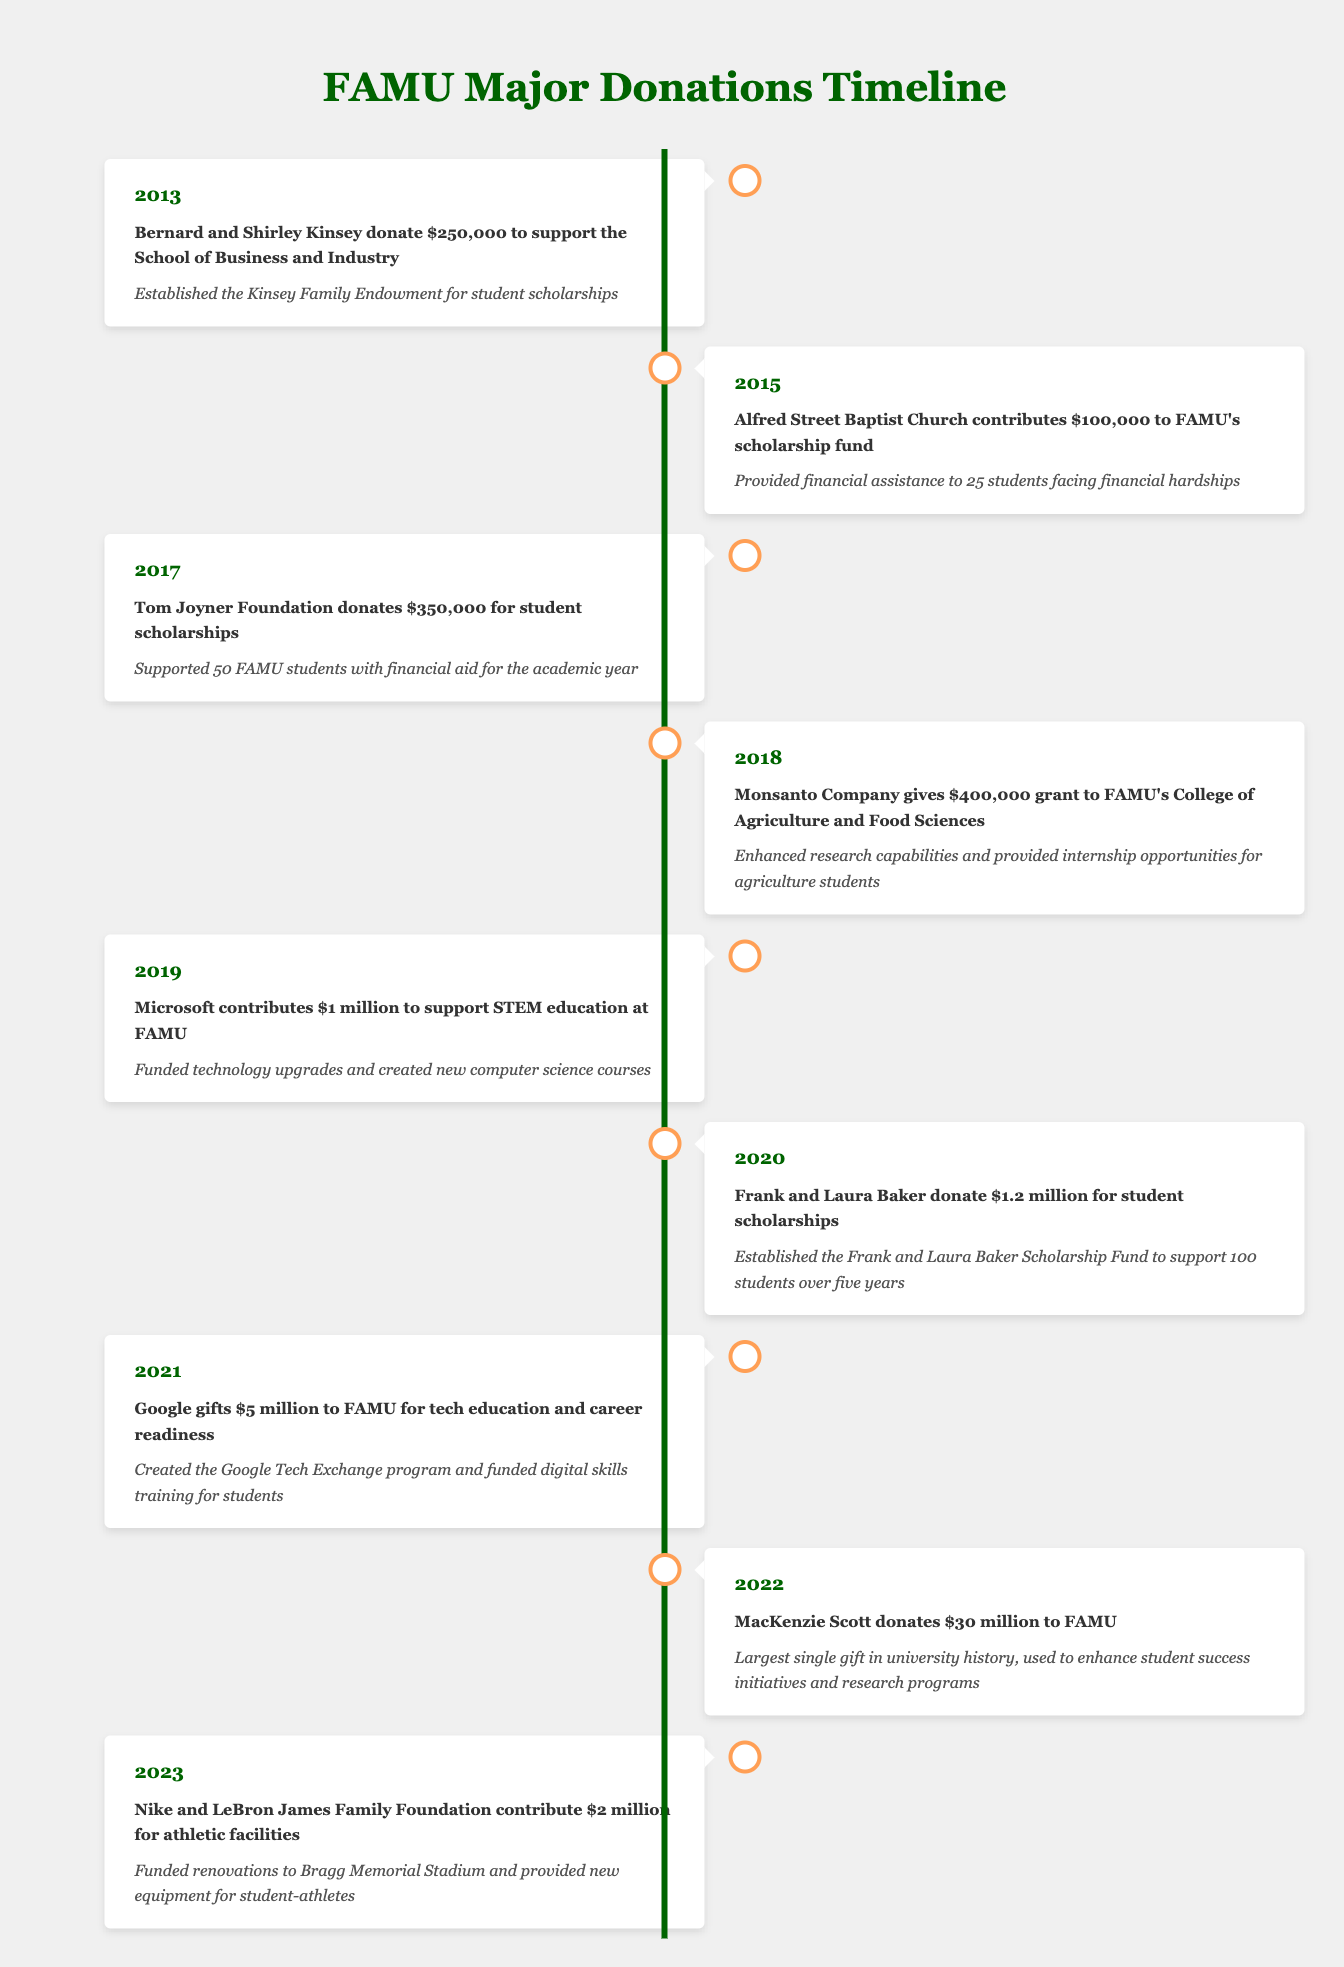What major donation did MacKenzie Scott make to FAMU? According to the timeline, MacKenzie Scott donated $30 million to FAMU in 2022.
Answer: $30 million Which event had the highest monetary contribution to FAMU? By comparing the monetary values from each event listed, the highest contribution is from MacKenzie Scott in 2022 with $30 million.
Answer: $30 million How many students did the Tom Joyner Foundation support with its donation? The timeline states that the Tom Joyner Foundation donated $350,000 in 2017 and supported 50 FAMU students with financial aid for the academic year.
Answer: 50 students Was the donation by Microsoft the only one exceeding $1 million? The timeline lists multiple donations exceeding $1 million, including those from Microsoft ($1 million), Frank and Laura Baker ($1.2 million), and Google ($5 million). Therefore, the statement is false.
Answer: No Calculate the total amount donated to FAMU in 2019 and 2020. In 2019, Microsoft donated $1 million, while in 2020, Frank and Laura Baker donated $1.2 million. Adding these amounts together gives $1 million + $1.2 million = $2.2 million.
Answer: $2.2 million What was the main focus of the donation made by Google in 2021? The table indicates that Google's donation of $5 million in 2021 focused on tech education and career readiness, specifically through the creation of the Google Tech Exchange program and funding for digital skills training.
Answer: Tech education and career readiness How many donations were made for student scholarships in the timeline? From reviewing the timeline, there are four distinct donations made explicitly for student scholarships: Kinsey Family Endowment in 2013, Tom Joyner Foundation in 2017, Frank and Laura Baker Scholarship Fund in 2020, and the 2022 MacKenzie Scott donation. Thus, there are four donations.
Answer: 4 donations What years had donations meant for athletic facilities? The only event linked specifically to athletic facilities was in 2023, with the donation by Nike and the LeBron James Family Foundation for renovations at Bragg Memorial Stadium.
Answer: 2023 In what way did Monsanto's 2018 donation benefit students? The timeline specifies that the $400,000 grant from Monsanto in 2018 enhanced research capabilities and provided internship opportunities specifically for agriculture students at FAMU.
Answer: Enhanced research and internship opportunities for agriculture students 